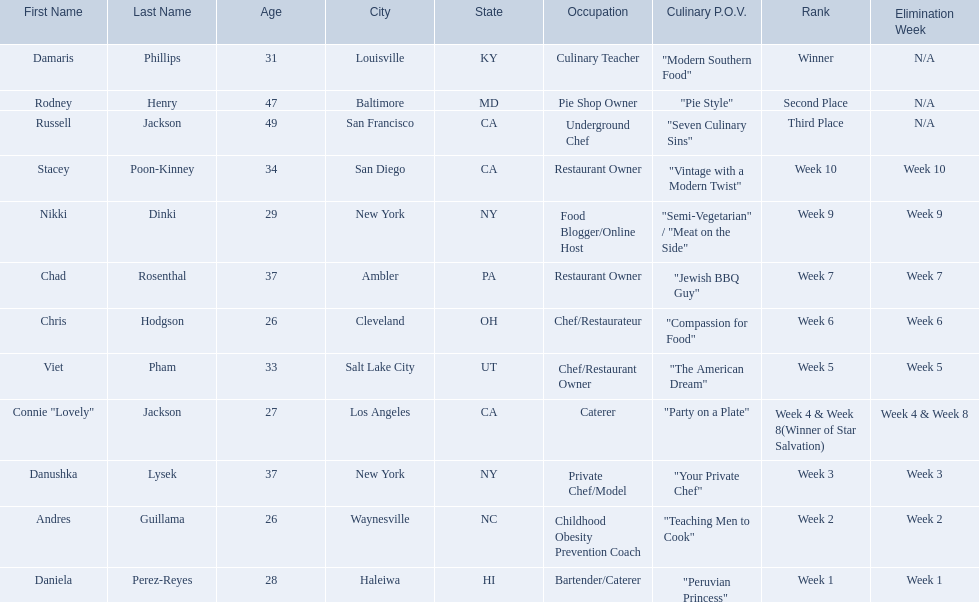Excluding the winner, and second and third place winners, who were the contestants eliminated? Stacey Poon-Kinney, Nikki Dinki, Chad Rosenthal, Chris Hodgson, Viet Pham, Connie "Lovely" Jackson, Danushka Lysek, Andres Guillama, Daniela Perez-Reyes. Of these contestants, who were the last five eliminated before the winner, second, and third place winners were announce? Stacey Poon-Kinney, Nikki Dinki, Chad Rosenthal, Chris Hodgson, Viet Pham. Of these five contestants, was nikki dinki or viet pham eliminated first? Viet Pham. 